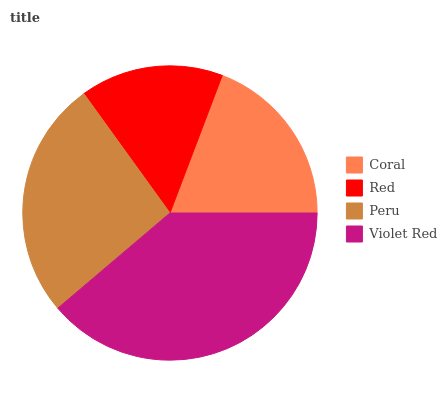Is Red the minimum?
Answer yes or no. Yes. Is Violet Red the maximum?
Answer yes or no. Yes. Is Peru the minimum?
Answer yes or no. No. Is Peru the maximum?
Answer yes or no. No. Is Peru greater than Red?
Answer yes or no. Yes. Is Red less than Peru?
Answer yes or no. Yes. Is Red greater than Peru?
Answer yes or no. No. Is Peru less than Red?
Answer yes or no. No. Is Peru the high median?
Answer yes or no. Yes. Is Coral the low median?
Answer yes or no. Yes. Is Red the high median?
Answer yes or no. No. Is Red the low median?
Answer yes or no. No. 